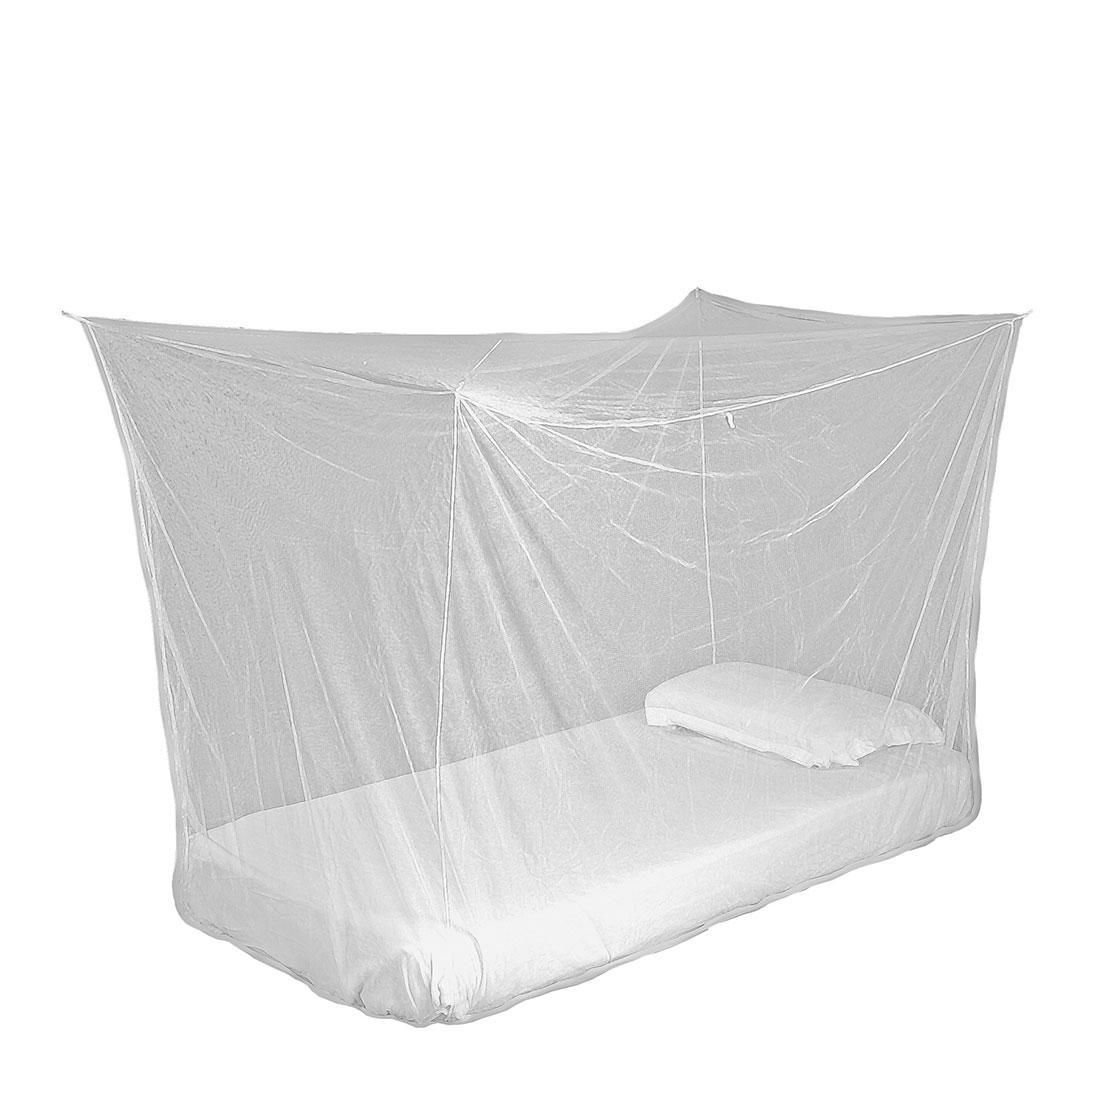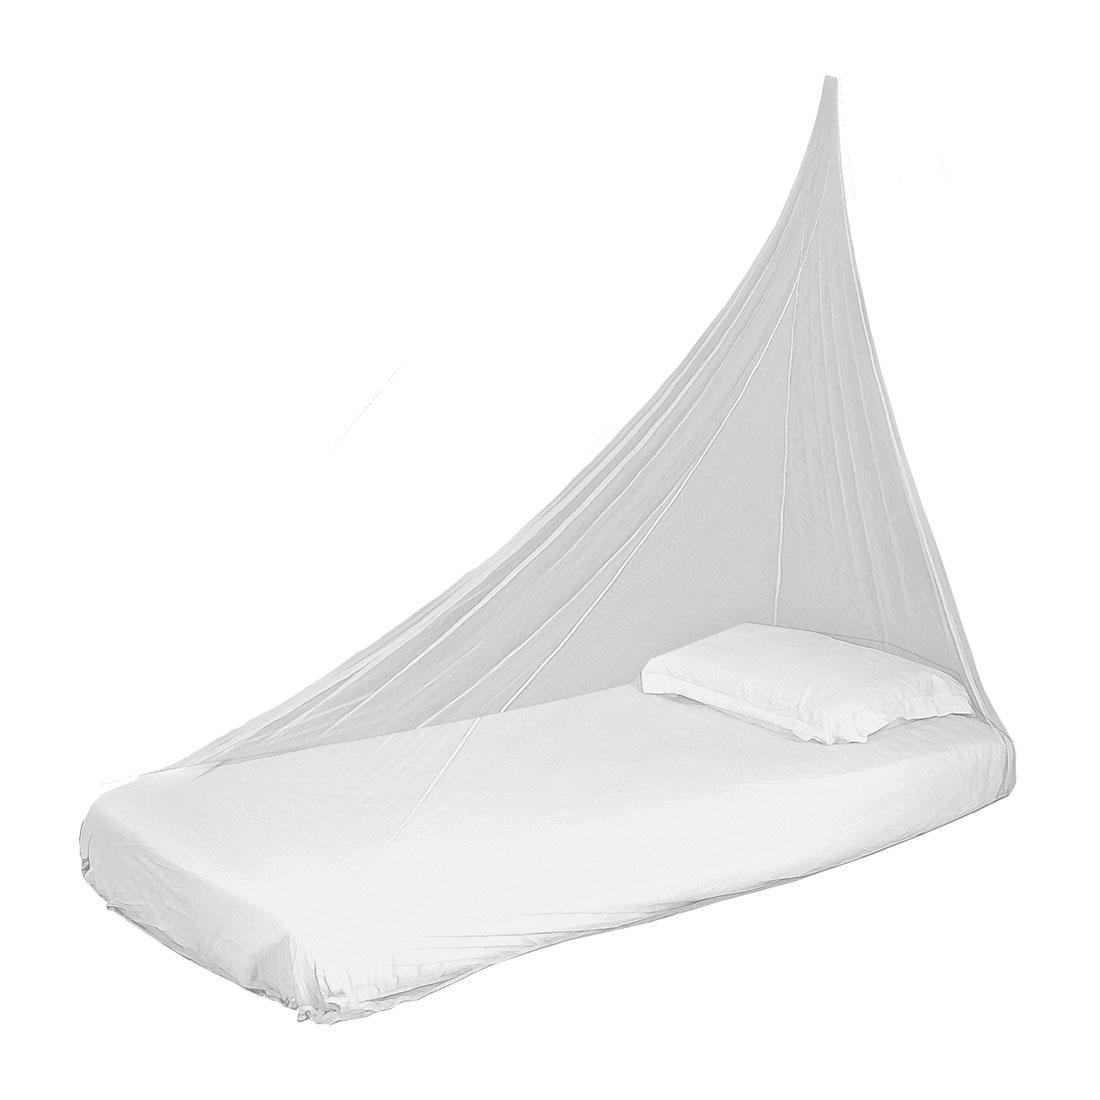The first image is the image on the left, the second image is the image on the right. Given the left and right images, does the statement "Two mattresses are completely covered by draped mosquito netting." hold true? Answer yes or no. Yes. The first image is the image on the left, the second image is the image on the right. Analyze the images presented: Is the assertion "One image on a white background shows a simple protective bed net that gathers to a point." valid? Answer yes or no. Yes. 